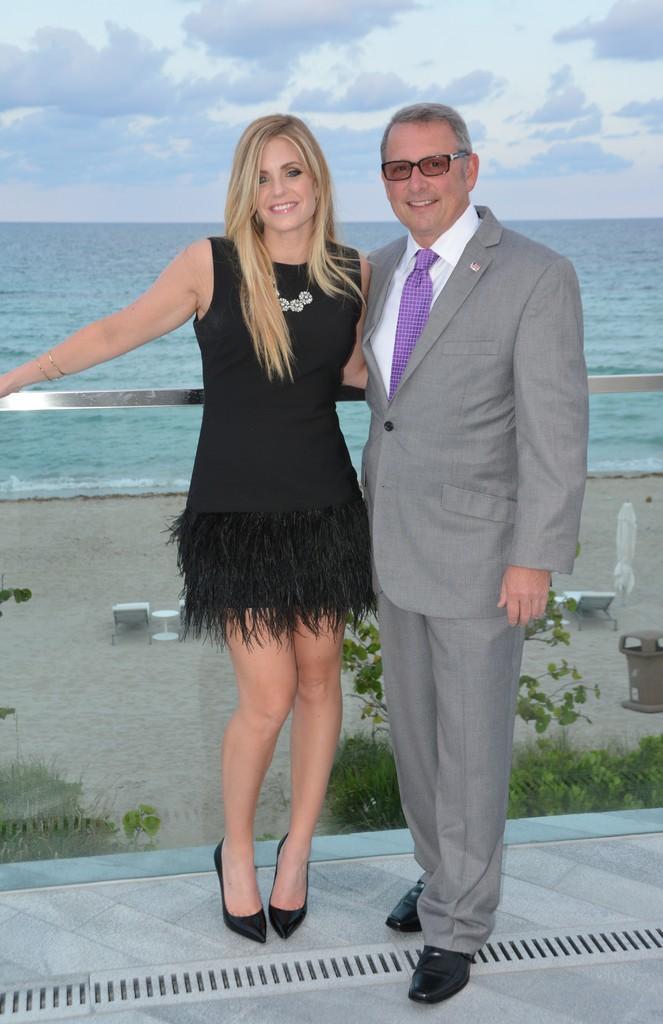In one or two sentences, can you explain what this image depicts? In the center of the image there are two people standing. In the background of the image there is water and sky. There is a glass railing through which we can see plants, table, sand and other objects. 